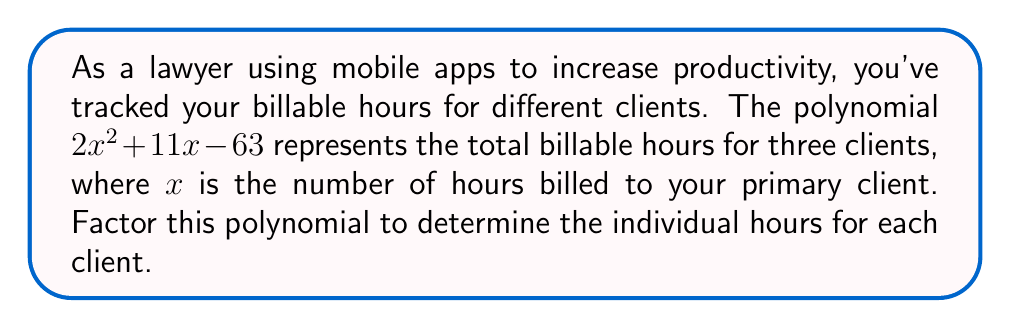Give your solution to this math problem. To factor the polynomial $2x^2 + 11x - 63$, we'll follow these steps:

1) First, we identify that this is a quadratic equation in the form $ax^2 + bx + c$, where:
   $a = 2$, $b = 11$, and $c = -63$

2) We'll use the ac-method for factoring:
   Multiply $a * c = 2 * (-63) = -126$

3) Find two numbers that multiply to give -126 and add up to b (11):
   $-9$ and $20$ satisfy this condition: $(-9 * 20 = -180)$ and $(-9 + 20 = 11)$

4) Rewrite the middle term using these numbers:
   $2x^2 - 9x + 20x - 63$

5) Group the terms:
   $(2x^2 - 9x) + (20x - 63)$

6) Factor out the common factors from each group:
   $x(2x - 9) + 7(2x - 9)$

7) Factor out the common binomial $(2x - 9)$:
   $(x + 7)(2x - 9)$

This factored form represents the billable hours for each client:
- $(x + 7)$ represents the hours for the primary client plus 7 hours for the second client
- $(2x - 9)$ represents twice the hours of the primary client minus 9 hours for the third client
Answer: $(x + 7)(2x - 9)$ 